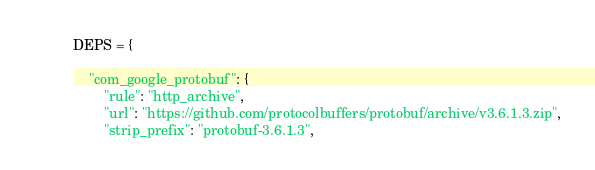Convert code to text. <code><loc_0><loc_0><loc_500><loc_500><_Python_>
DEPS = {

    "com_google_protobuf": {
        "rule": "http_archive",
        "url": "https://github.com/protocolbuffers/protobuf/archive/v3.6.1.3.zip",
        "strip_prefix": "protobuf-3.6.1.3",</code> 